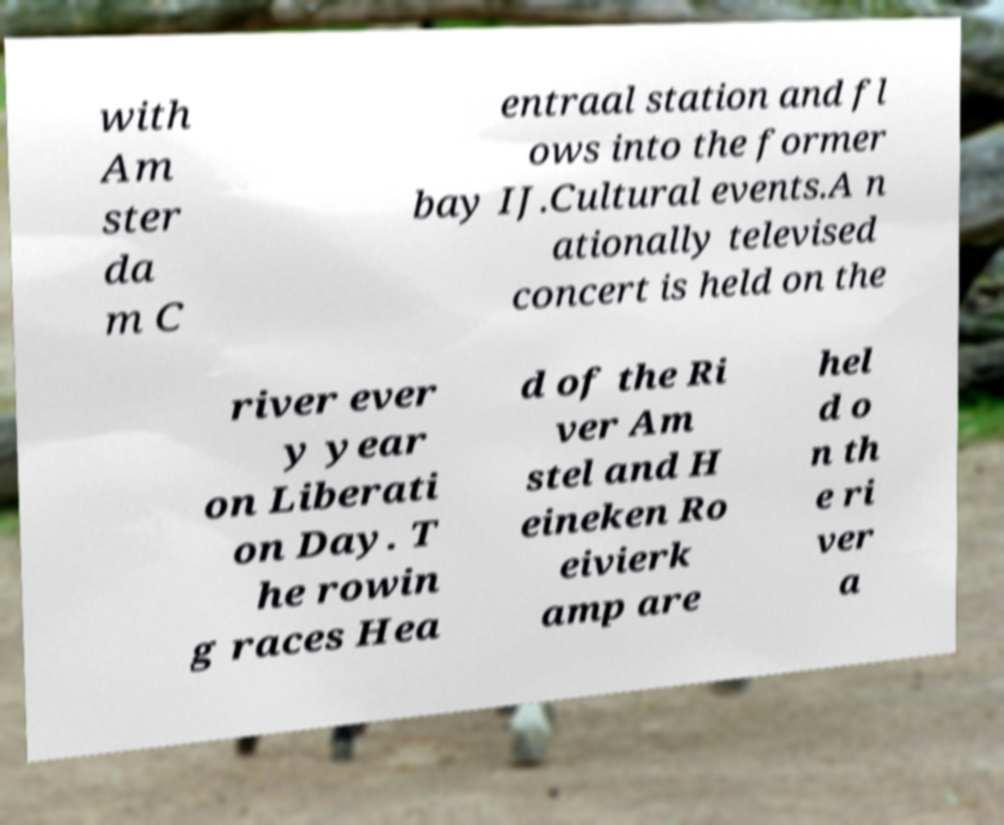Could you extract and type out the text from this image? with Am ster da m C entraal station and fl ows into the former bay IJ.Cultural events.A n ationally televised concert is held on the river ever y year on Liberati on Day. T he rowin g races Hea d of the Ri ver Am stel and H eineken Ro eivierk amp are hel d o n th e ri ver a 